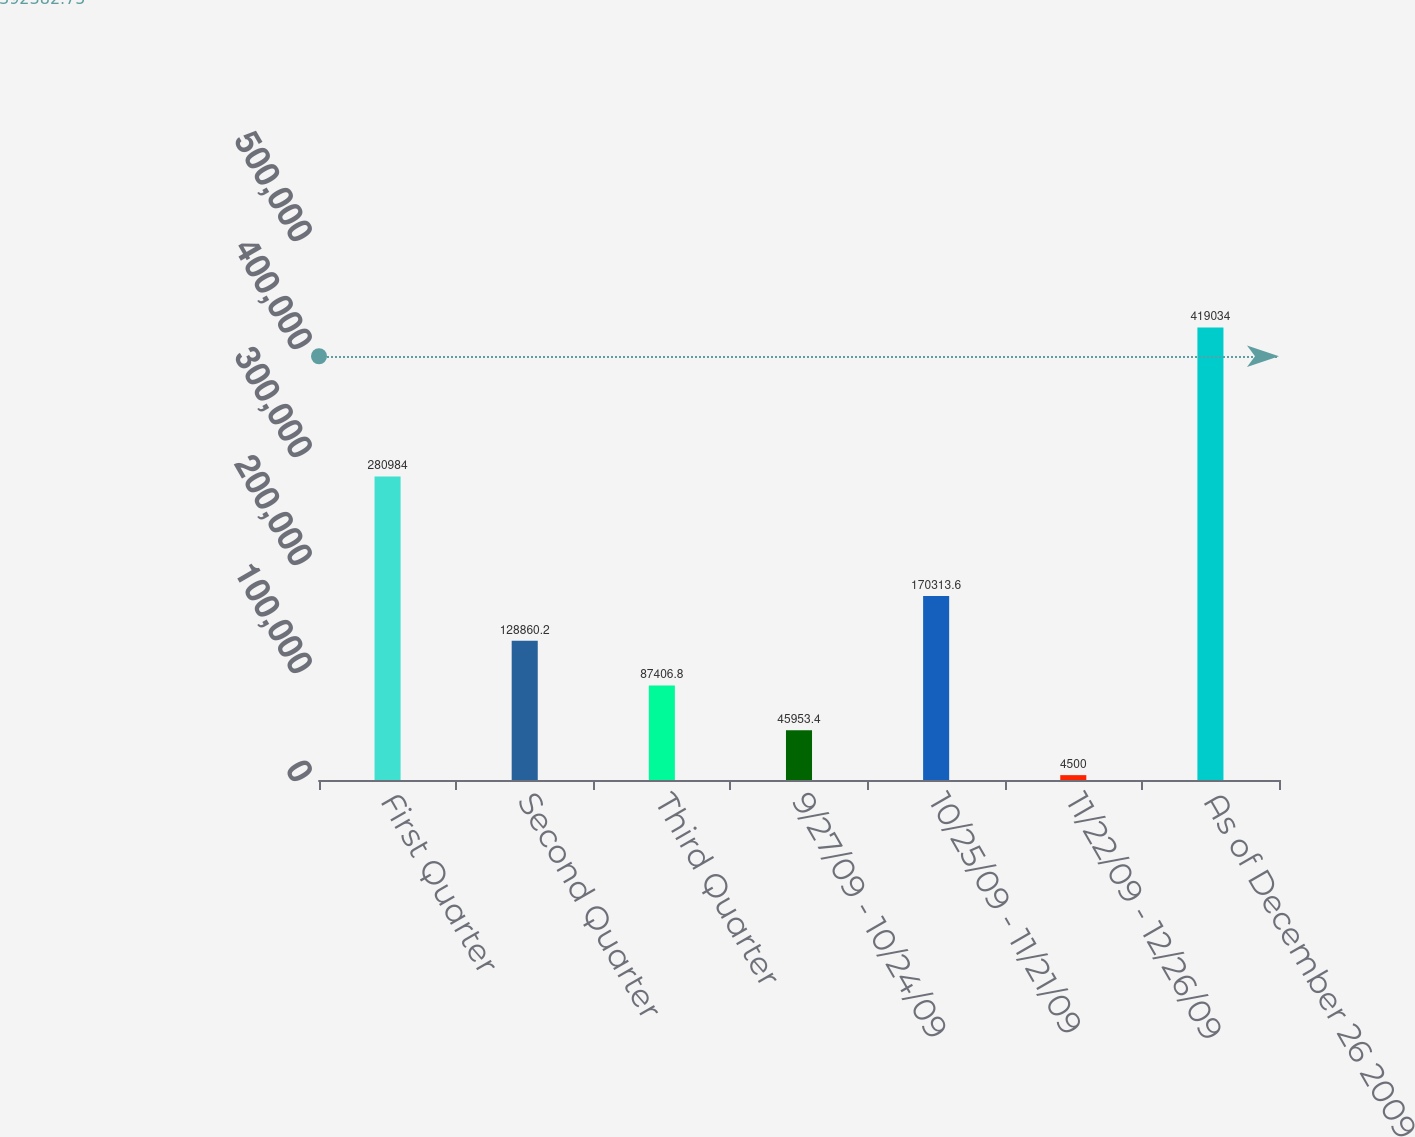<chart> <loc_0><loc_0><loc_500><loc_500><bar_chart><fcel>First Quarter<fcel>Second Quarter<fcel>Third Quarter<fcel>9/27/09 - 10/24/09<fcel>10/25/09 - 11/21/09<fcel>11/22/09 - 12/26/09<fcel>As of December 26 2009<nl><fcel>280984<fcel>128860<fcel>87406.8<fcel>45953.4<fcel>170314<fcel>4500<fcel>419034<nl></chart> 